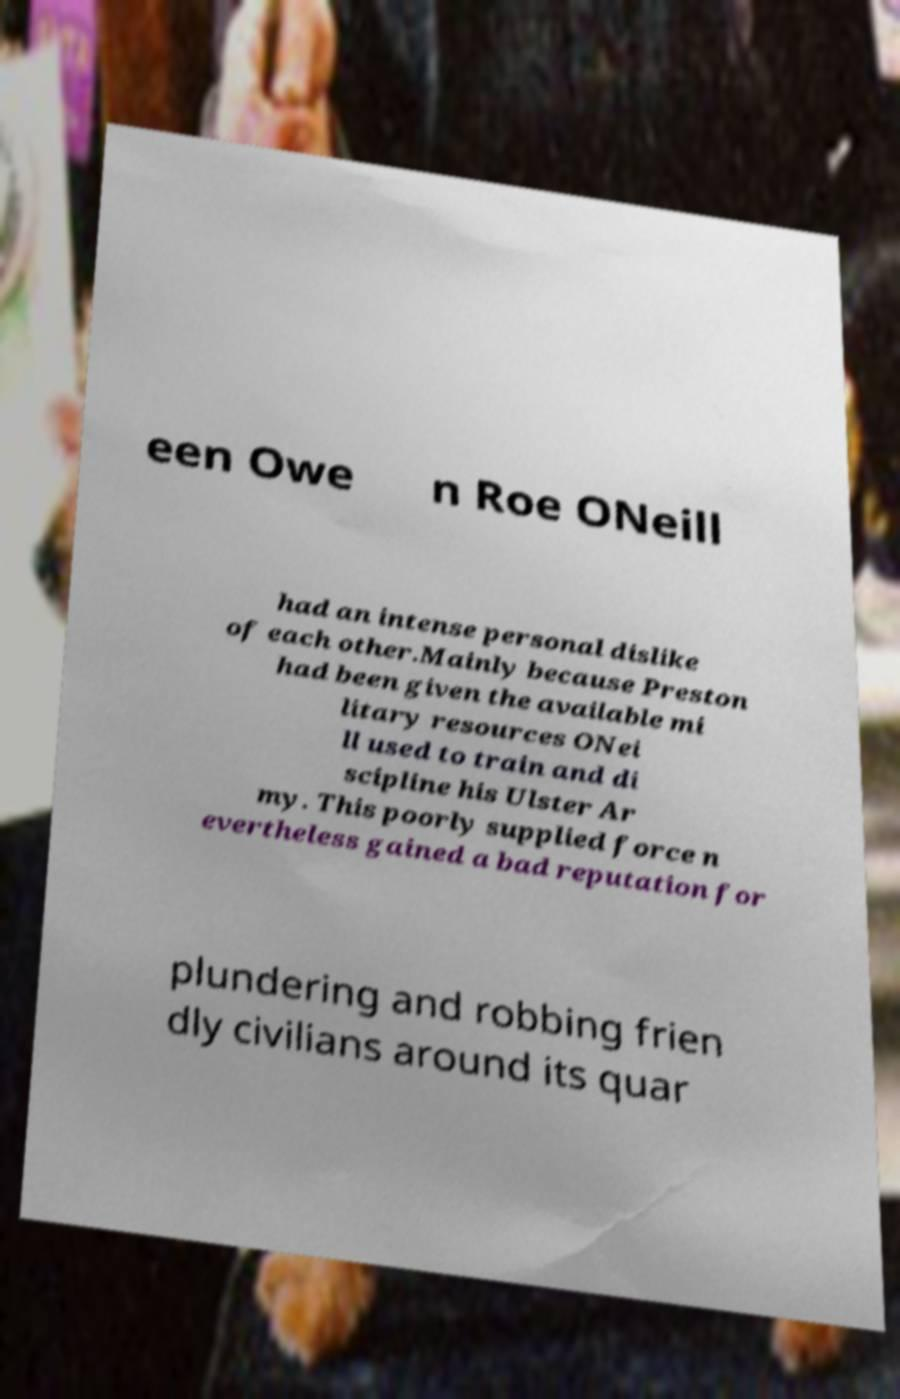I need the written content from this picture converted into text. Can you do that? een Owe n Roe ONeill had an intense personal dislike of each other.Mainly because Preston had been given the available mi litary resources ONei ll used to train and di scipline his Ulster Ar my. This poorly supplied force n evertheless gained a bad reputation for plundering and robbing frien dly civilians around its quar 